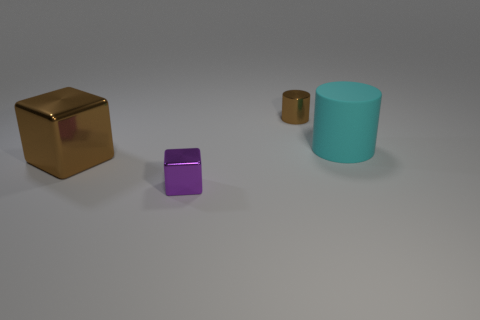Is there anything else that is made of the same material as the cyan object?
Your answer should be compact. No. Is the matte object the same shape as the large brown thing?
Your answer should be compact. No. What number of objects are things that are on the left side of the matte thing or green shiny cylinders?
Keep it short and to the point. 3. Are there an equal number of large metal blocks that are behind the tiny shiny cylinder and big things behind the cyan cylinder?
Give a very brief answer. Yes. How many other things are the same shape as the cyan thing?
Provide a short and direct response. 1. Is the size of the brown thing that is in front of the rubber cylinder the same as the brown thing that is behind the brown shiny cube?
Make the answer very short. No. How many balls are small cyan objects or tiny metallic objects?
Make the answer very short. 0. How many metallic things are either brown cylinders or big green balls?
Your response must be concise. 1. The other object that is the same shape as the purple shiny thing is what size?
Provide a short and direct response. Large. Is there anything else that is the same size as the cyan thing?
Your answer should be compact. Yes. 